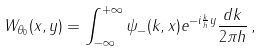<formula> <loc_0><loc_0><loc_500><loc_500>W _ { \theta _ { 0 } } ( x , y ) = \int _ { - \infty } ^ { + \infty } \psi _ { - } ( k , x ) e ^ { - i \frac { k } { h } y } \frac { d k } { 2 \pi h } \, ,</formula> 